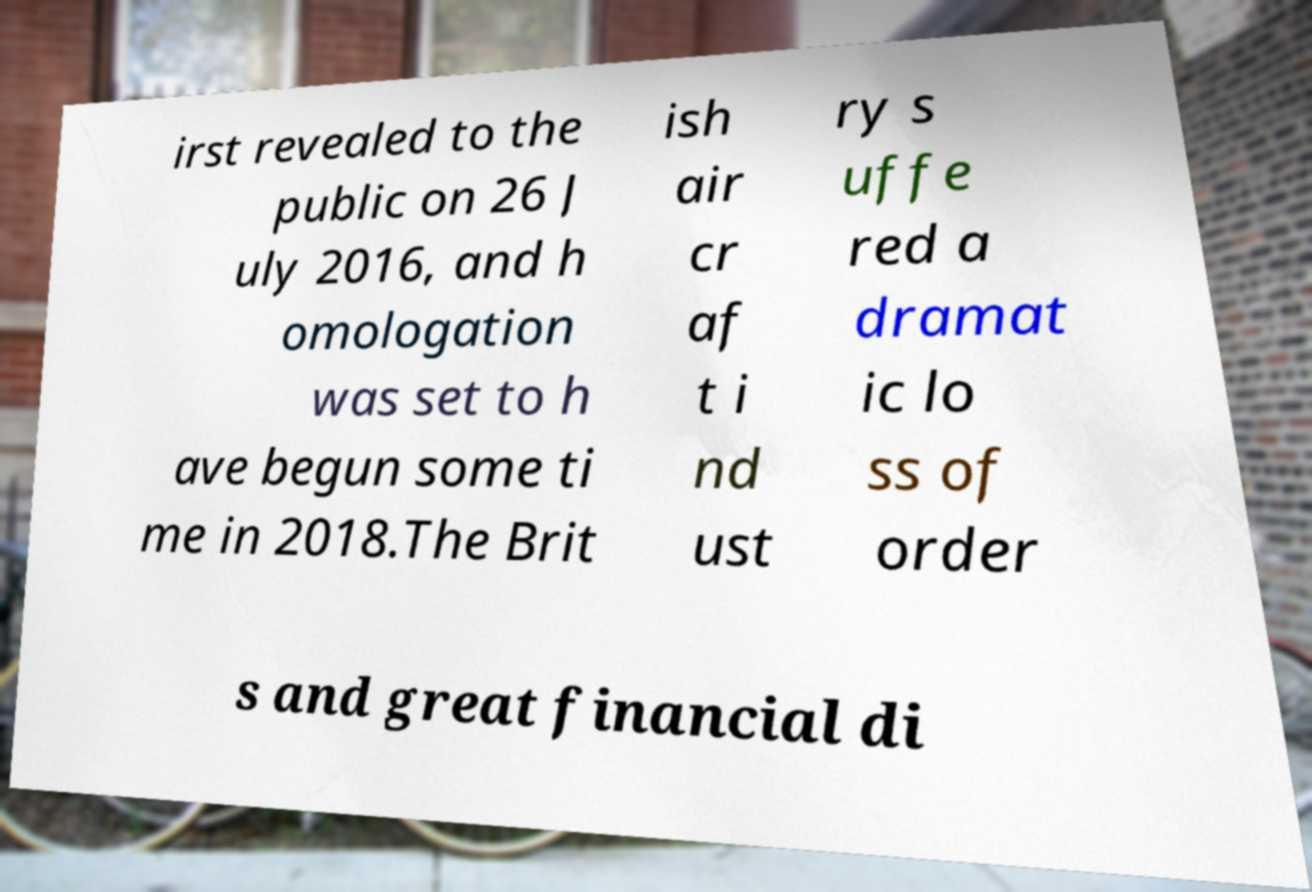Can you accurately transcribe the text from the provided image for me? irst revealed to the public on 26 J uly 2016, and h omologation was set to h ave begun some ti me in 2018.The Brit ish air cr af t i nd ust ry s uffe red a dramat ic lo ss of order s and great financial di 